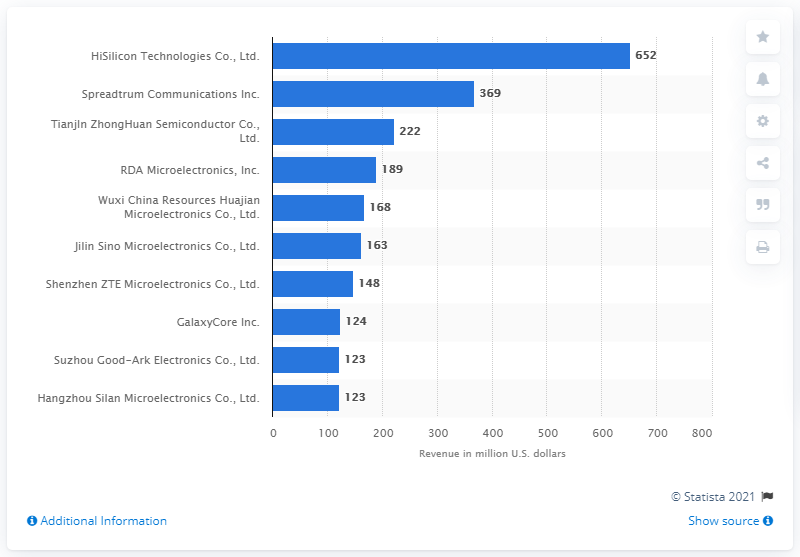List a handful of essential elements in this visual. Tianjln ZhongHuan Semiconductor Co generated a total of approximately 222 million US dollars in the United States in 2010. 